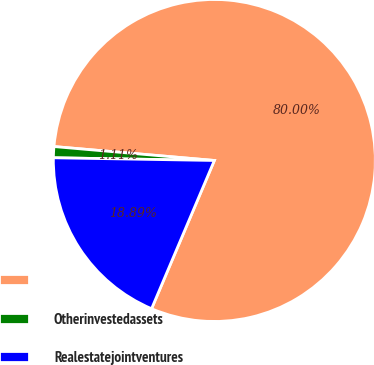<chart> <loc_0><loc_0><loc_500><loc_500><pie_chart><ecel><fcel>Otherinvestedassets<fcel>Realestatejointventures<nl><fcel>80.0%<fcel>1.11%<fcel>18.89%<nl></chart> 